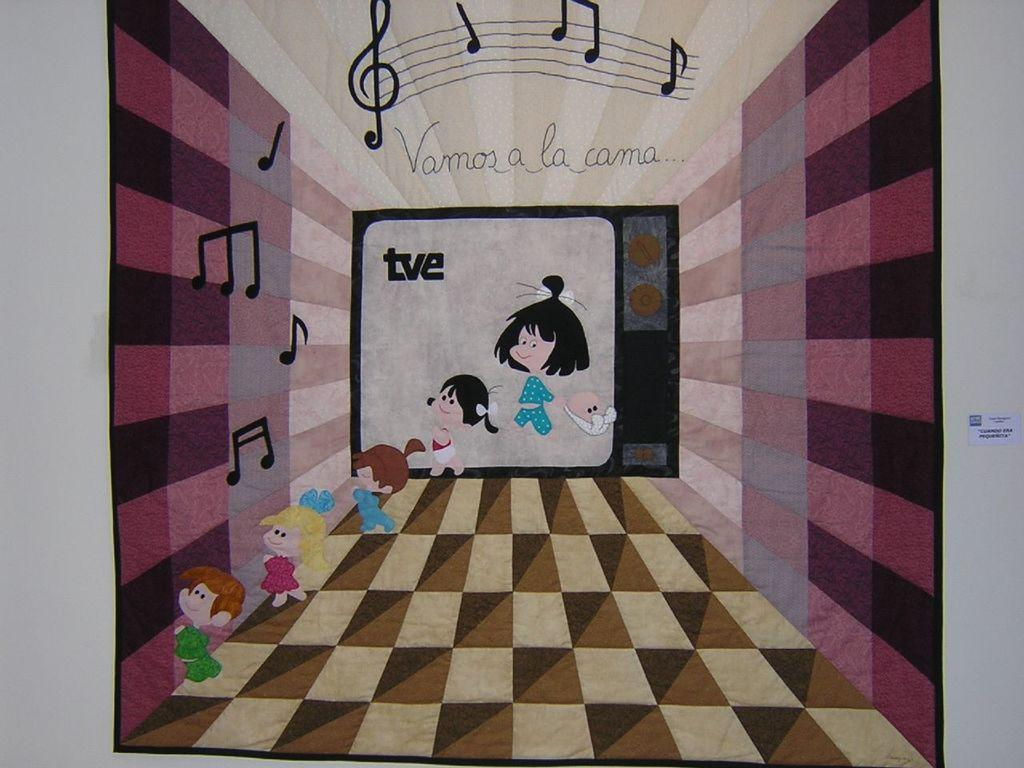<image>
Summarize the visual content of the image. a television that has tve written on it 